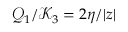<formula> <loc_0><loc_0><loc_500><loc_500>\mathcal { Q } _ { 1 } / \mathcal { K } _ { 3 } = 2 \eta / | z |</formula> 